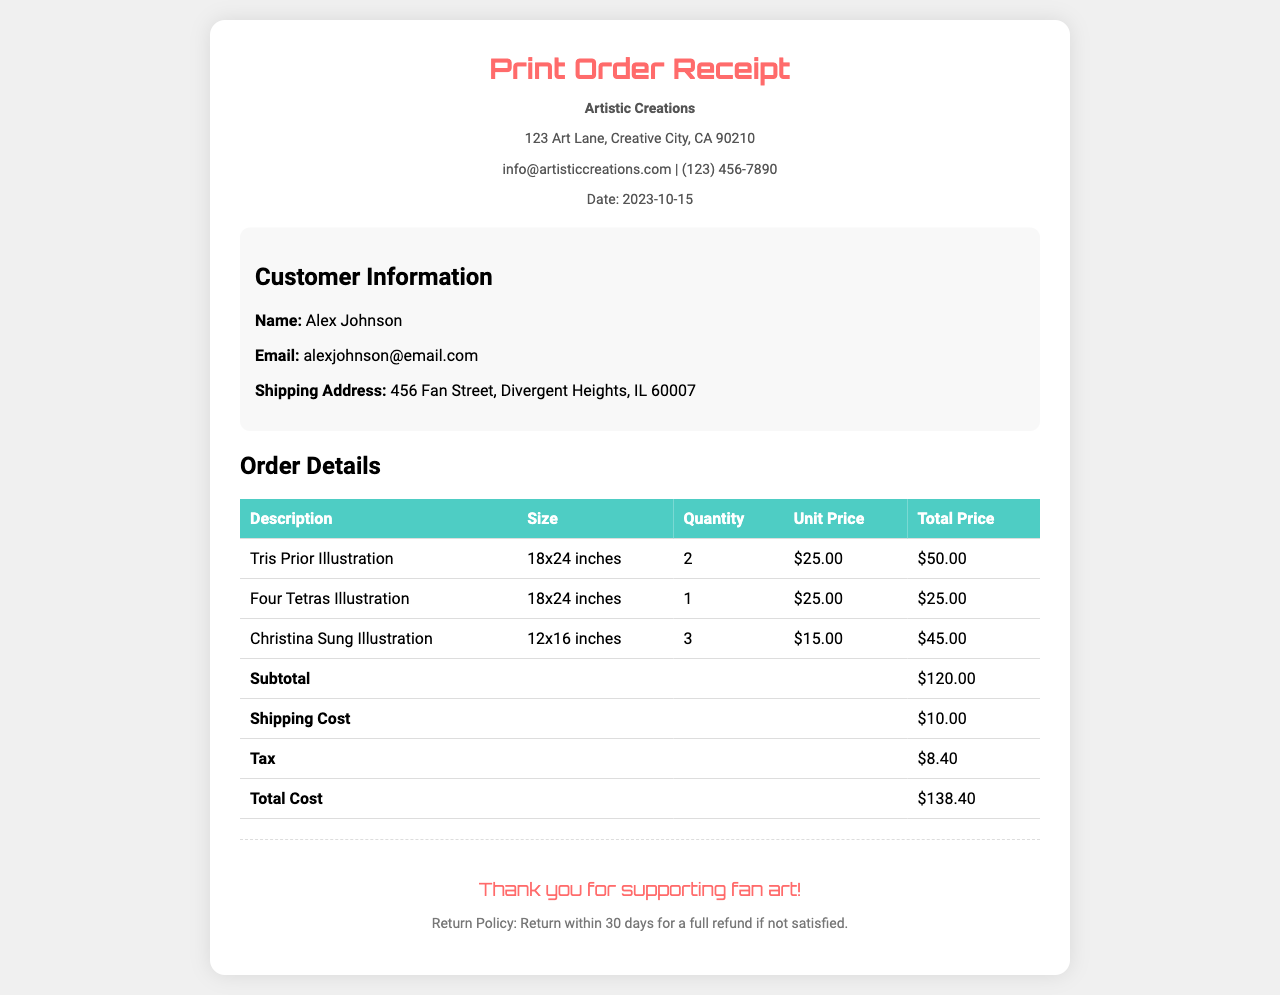What is the customer's name? The customer's name is indicated in the customer information section of the receipt.
Answer: Alex Johnson What is the total cost of the order? The total cost is summarized at the bottom of the order details table.
Answer: $138.40 How many "Tris Prior Illustration" prints were ordered? The quantity of "Tris Prior Illustration" prints can be found in the order details section of the document.
Answer: 2 What is the shipping cost? The shipping cost is listed in the order details as a separate line item.
Answer: $10.00 What size is the "Christina Sung Illustration"? The size of the "Christina Sung Illustration" is specified in its respective row in the order details table.
Answer: 12x16 inches What date was the order placed? The date of the order is stated in the header of the receipt.
Answer: 2023-10-15 What is the subtotal amount before shipping and tax? The subtotal is calculated from the total prices of all items before adding shipping and tax.
Answer: $120.00 How many different illustrations are ordered? The number of unique illustrations can be counted from the different descriptions listed in the order details.
Answer: 3 What is the return policy? The return policy is mentioned in the footer of the receipt.
Answer: Return within 30 days for a full refund if not satisfied 